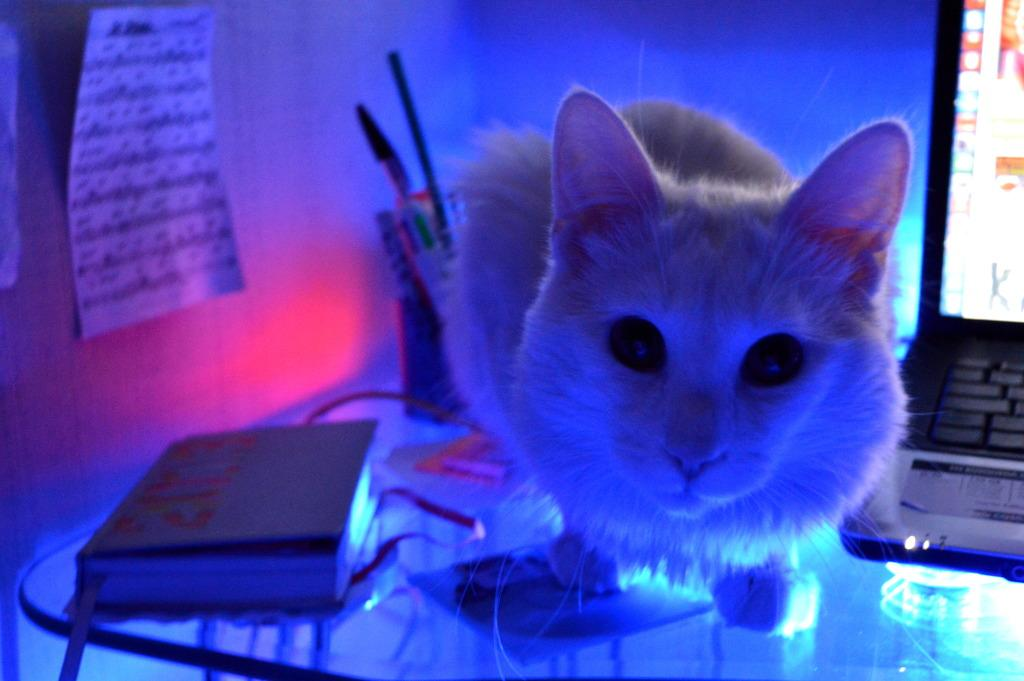What animal is on the table in the image? There is a cat on the table in the image. What electronic device is on the table? There is a laptop on the table. What reading material is on the table? There is a book on the table. What writing instruments are on the table? There are pens on the table. What can be seen in the background of the image? There is a wall in the background, and a paper is on the wall. Is there a quill on the table in the image? There is no quill present in the image. Can you see a nest in the image? There is no nest present in the image. 